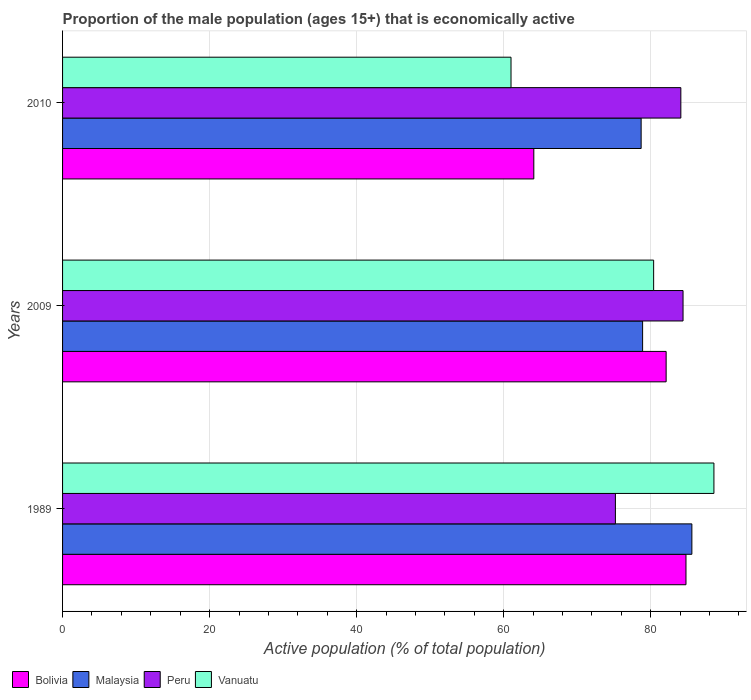Are the number of bars per tick equal to the number of legend labels?
Give a very brief answer. Yes. Are the number of bars on each tick of the Y-axis equal?
Give a very brief answer. Yes. How many bars are there on the 3rd tick from the top?
Provide a short and direct response. 4. What is the label of the 1st group of bars from the top?
Keep it short and to the point. 2010. What is the proportion of the male population that is economically active in Vanuatu in 1989?
Offer a terse response. 88.6. Across all years, what is the maximum proportion of the male population that is economically active in Malaysia?
Your answer should be compact. 85.6. Across all years, what is the minimum proportion of the male population that is economically active in Peru?
Give a very brief answer. 75.2. In which year was the proportion of the male population that is economically active in Peru minimum?
Your response must be concise. 1989. What is the total proportion of the male population that is economically active in Bolivia in the graph?
Your response must be concise. 231. What is the difference between the proportion of the male population that is economically active in Bolivia in 2009 and that in 2010?
Provide a succinct answer. 18. What is the difference between the proportion of the male population that is economically active in Vanuatu in 2010 and the proportion of the male population that is economically active in Malaysia in 1989?
Offer a terse response. -24.6. What is the average proportion of the male population that is economically active in Peru per year?
Make the answer very short. 81.23. In how many years, is the proportion of the male population that is economically active in Malaysia greater than 44 %?
Your answer should be very brief. 3. What is the ratio of the proportion of the male population that is economically active in Bolivia in 1989 to that in 2009?
Your answer should be very brief. 1.03. Is the proportion of the male population that is economically active in Peru in 1989 less than that in 2010?
Offer a very short reply. Yes. Is the difference between the proportion of the male population that is economically active in Peru in 1989 and 2009 greater than the difference between the proportion of the male population that is economically active in Bolivia in 1989 and 2009?
Your answer should be compact. No. What is the difference between the highest and the second highest proportion of the male population that is economically active in Bolivia?
Give a very brief answer. 2.7. What is the difference between the highest and the lowest proportion of the male population that is economically active in Bolivia?
Your response must be concise. 20.7. Is the sum of the proportion of the male population that is economically active in Malaysia in 1989 and 2009 greater than the maximum proportion of the male population that is economically active in Peru across all years?
Offer a very short reply. Yes. What does the 1st bar from the top in 1989 represents?
Keep it short and to the point. Vanuatu. What does the 4th bar from the bottom in 1989 represents?
Give a very brief answer. Vanuatu. Is it the case that in every year, the sum of the proportion of the male population that is economically active in Malaysia and proportion of the male population that is economically active in Vanuatu is greater than the proportion of the male population that is economically active in Peru?
Your response must be concise. Yes. How many bars are there?
Provide a short and direct response. 12. Are all the bars in the graph horizontal?
Make the answer very short. Yes. How many years are there in the graph?
Your response must be concise. 3. Are the values on the major ticks of X-axis written in scientific E-notation?
Your answer should be compact. No. Where does the legend appear in the graph?
Provide a succinct answer. Bottom left. How many legend labels are there?
Make the answer very short. 4. How are the legend labels stacked?
Make the answer very short. Horizontal. What is the title of the graph?
Offer a very short reply. Proportion of the male population (ages 15+) that is economically active. What is the label or title of the X-axis?
Provide a short and direct response. Active population (% of total population). What is the label or title of the Y-axis?
Provide a succinct answer. Years. What is the Active population (% of total population) in Bolivia in 1989?
Your answer should be very brief. 84.8. What is the Active population (% of total population) of Malaysia in 1989?
Give a very brief answer. 85.6. What is the Active population (% of total population) in Peru in 1989?
Give a very brief answer. 75.2. What is the Active population (% of total population) in Vanuatu in 1989?
Give a very brief answer. 88.6. What is the Active population (% of total population) in Bolivia in 2009?
Offer a terse response. 82.1. What is the Active population (% of total population) in Malaysia in 2009?
Provide a succinct answer. 78.9. What is the Active population (% of total population) of Peru in 2009?
Give a very brief answer. 84.4. What is the Active population (% of total population) in Vanuatu in 2009?
Give a very brief answer. 80.4. What is the Active population (% of total population) in Bolivia in 2010?
Make the answer very short. 64.1. What is the Active population (% of total population) of Malaysia in 2010?
Your answer should be very brief. 78.7. What is the Active population (% of total population) in Peru in 2010?
Your response must be concise. 84.1. What is the Active population (% of total population) of Vanuatu in 2010?
Keep it short and to the point. 61. Across all years, what is the maximum Active population (% of total population) of Bolivia?
Your response must be concise. 84.8. Across all years, what is the maximum Active population (% of total population) in Malaysia?
Give a very brief answer. 85.6. Across all years, what is the maximum Active population (% of total population) in Peru?
Keep it short and to the point. 84.4. Across all years, what is the maximum Active population (% of total population) in Vanuatu?
Your answer should be very brief. 88.6. Across all years, what is the minimum Active population (% of total population) in Bolivia?
Give a very brief answer. 64.1. Across all years, what is the minimum Active population (% of total population) of Malaysia?
Provide a short and direct response. 78.7. Across all years, what is the minimum Active population (% of total population) in Peru?
Your answer should be compact. 75.2. What is the total Active population (% of total population) of Bolivia in the graph?
Provide a short and direct response. 231. What is the total Active population (% of total population) of Malaysia in the graph?
Offer a terse response. 243.2. What is the total Active population (% of total population) in Peru in the graph?
Ensure brevity in your answer.  243.7. What is the total Active population (% of total population) in Vanuatu in the graph?
Give a very brief answer. 230. What is the difference between the Active population (% of total population) in Bolivia in 1989 and that in 2009?
Provide a succinct answer. 2.7. What is the difference between the Active population (% of total population) of Malaysia in 1989 and that in 2009?
Your answer should be very brief. 6.7. What is the difference between the Active population (% of total population) in Peru in 1989 and that in 2009?
Provide a succinct answer. -9.2. What is the difference between the Active population (% of total population) in Vanuatu in 1989 and that in 2009?
Provide a succinct answer. 8.2. What is the difference between the Active population (% of total population) of Bolivia in 1989 and that in 2010?
Your response must be concise. 20.7. What is the difference between the Active population (% of total population) in Peru in 1989 and that in 2010?
Make the answer very short. -8.9. What is the difference between the Active population (% of total population) in Vanuatu in 1989 and that in 2010?
Provide a succinct answer. 27.6. What is the difference between the Active population (% of total population) in Bolivia in 2009 and that in 2010?
Provide a succinct answer. 18. What is the difference between the Active population (% of total population) in Malaysia in 2009 and that in 2010?
Provide a short and direct response. 0.2. What is the difference between the Active population (% of total population) in Vanuatu in 2009 and that in 2010?
Your answer should be very brief. 19.4. What is the difference between the Active population (% of total population) in Bolivia in 1989 and the Active population (% of total population) in Malaysia in 2009?
Keep it short and to the point. 5.9. What is the difference between the Active population (% of total population) in Bolivia in 1989 and the Active population (% of total population) in Vanuatu in 2009?
Offer a terse response. 4.4. What is the difference between the Active population (% of total population) of Malaysia in 1989 and the Active population (% of total population) of Peru in 2009?
Provide a succinct answer. 1.2. What is the difference between the Active population (% of total population) in Malaysia in 1989 and the Active population (% of total population) in Vanuatu in 2009?
Offer a very short reply. 5.2. What is the difference between the Active population (% of total population) in Bolivia in 1989 and the Active population (% of total population) in Peru in 2010?
Keep it short and to the point. 0.7. What is the difference between the Active population (% of total population) of Bolivia in 1989 and the Active population (% of total population) of Vanuatu in 2010?
Offer a very short reply. 23.8. What is the difference between the Active population (% of total population) of Malaysia in 1989 and the Active population (% of total population) of Peru in 2010?
Ensure brevity in your answer.  1.5. What is the difference between the Active population (% of total population) of Malaysia in 1989 and the Active population (% of total population) of Vanuatu in 2010?
Give a very brief answer. 24.6. What is the difference between the Active population (% of total population) in Peru in 1989 and the Active population (% of total population) in Vanuatu in 2010?
Provide a short and direct response. 14.2. What is the difference between the Active population (% of total population) of Bolivia in 2009 and the Active population (% of total population) of Malaysia in 2010?
Offer a very short reply. 3.4. What is the difference between the Active population (% of total population) in Bolivia in 2009 and the Active population (% of total population) in Peru in 2010?
Ensure brevity in your answer.  -2. What is the difference between the Active population (% of total population) in Bolivia in 2009 and the Active population (% of total population) in Vanuatu in 2010?
Offer a terse response. 21.1. What is the difference between the Active population (% of total population) of Malaysia in 2009 and the Active population (% of total population) of Vanuatu in 2010?
Provide a short and direct response. 17.9. What is the difference between the Active population (% of total population) in Peru in 2009 and the Active population (% of total population) in Vanuatu in 2010?
Keep it short and to the point. 23.4. What is the average Active population (% of total population) of Bolivia per year?
Provide a succinct answer. 77. What is the average Active population (% of total population) of Malaysia per year?
Provide a short and direct response. 81.07. What is the average Active population (% of total population) of Peru per year?
Offer a terse response. 81.23. What is the average Active population (% of total population) in Vanuatu per year?
Keep it short and to the point. 76.67. In the year 1989, what is the difference between the Active population (% of total population) of Bolivia and Active population (% of total population) of Malaysia?
Your answer should be very brief. -0.8. In the year 1989, what is the difference between the Active population (% of total population) of Bolivia and Active population (% of total population) of Peru?
Offer a terse response. 9.6. In the year 1989, what is the difference between the Active population (% of total population) of Peru and Active population (% of total population) of Vanuatu?
Ensure brevity in your answer.  -13.4. In the year 2009, what is the difference between the Active population (% of total population) in Bolivia and Active population (% of total population) in Malaysia?
Offer a very short reply. 3.2. In the year 2009, what is the difference between the Active population (% of total population) in Bolivia and Active population (% of total population) in Vanuatu?
Keep it short and to the point. 1.7. In the year 2009, what is the difference between the Active population (% of total population) of Peru and Active population (% of total population) of Vanuatu?
Ensure brevity in your answer.  4. In the year 2010, what is the difference between the Active population (% of total population) in Bolivia and Active population (% of total population) in Malaysia?
Provide a succinct answer. -14.6. In the year 2010, what is the difference between the Active population (% of total population) of Peru and Active population (% of total population) of Vanuatu?
Provide a short and direct response. 23.1. What is the ratio of the Active population (% of total population) in Bolivia in 1989 to that in 2009?
Offer a terse response. 1.03. What is the ratio of the Active population (% of total population) of Malaysia in 1989 to that in 2009?
Provide a short and direct response. 1.08. What is the ratio of the Active population (% of total population) of Peru in 1989 to that in 2009?
Keep it short and to the point. 0.89. What is the ratio of the Active population (% of total population) of Vanuatu in 1989 to that in 2009?
Keep it short and to the point. 1.1. What is the ratio of the Active population (% of total population) in Bolivia in 1989 to that in 2010?
Your response must be concise. 1.32. What is the ratio of the Active population (% of total population) of Malaysia in 1989 to that in 2010?
Ensure brevity in your answer.  1.09. What is the ratio of the Active population (% of total population) in Peru in 1989 to that in 2010?
Keep it short and to the point. 0.89. What is the ratio of the Active population (% of total population) in Vanuatu in 1989 to that in 2010?
Make the answer very short. 1.45. What is the ratio of the Active population (% of total population) of Bolivia in 2009 to that in 2010?
Your response must be concise. 1.28. What is the ratio of the Active population (% of total population) in Malaysia in 2009 to that in 2010?
Your response must be concise. 1. What is the ratio of the Active population (% of total population) of Peru in 2009 to that in 2010?
Keep it short and to the point. 1. What is the ratio of the Active population (% of total population) of Vanuatu in 2009 to that in 2010?
Ensure brevity in your answer.  1.32. What is the difference between the highest and the second highest Active population (% of total population) of Bolivia?
Ensure brevity in your answer.  2.7. What is the difference between the highest and the second highest Active population (% of total population) of Malaysia?
Provide a short and direct response. 6.7. What is the difference between the highest and the lowest Active population (% of total population) of Bolivia?
Offer a very short reply. 20.7. What is the difference between the highest and the lowest Active population (% of total population) of Malaysia?
Offer a terse response. 6.9. What is the difference between the highest and the lowest Active population (% of total population) in Peru?
Your answer should be compact. 9.2. What is the difference between the highest and the lowest Active population (% of total population) in Vanuatu?
Provide a short and direct response. 27.6. 